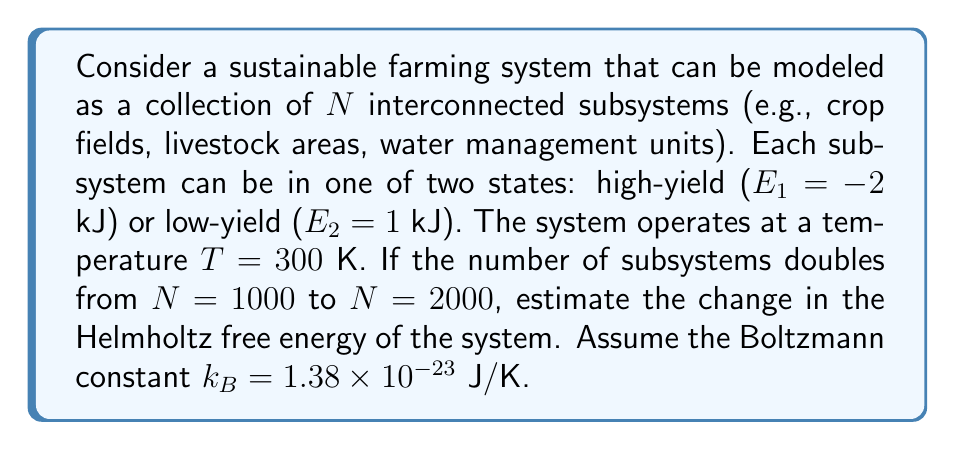Could you help me with this problem? To solve this problem, we'll use the Helmholtz free energy formula and calculate the difference between the two scales:

1) The Helmholtz free energy is given by:
   $$F = -k_B T \ln Z$$
   where $Z$ is the partition function.

2) For a two-state system, the partition function is:
   $$Z = e^{-\beta E_1} + e^{-\beta E_2}$$
   where $\beta = \frac{1}{k_B T}$

3) Calculate $\beta$:
   $$\beta = \frac{1}{(1.38 \times 10^{-23} \text{ J/K})(300 \text{ K})} = 2.415 \times 10^{20} \text{ J}^{-1}$$

4) Calculate $Z$ for a single subsystem:
   $$Z = e^{-(2.415 \times 10^{20} \text{ J}^{-1})(-2 \times 10^{-3} \text{ J})} + e^{-(2.415 \times 10^{20} \text{ J}^{-1})(1 \times 10^{-3} \text{ J})}$$
   $$Z = e^{4.83 \times 10^{17}} + e^{-2.415 \times 10^{17}} \approx e^{4.83 \times 10^{17}}$$

5) For $N$ independent subsystems, $Z_N = Z^N$. So, the free energy for $N$ subsystems is:
   $$F_N = -k_B T N \ln Z$$

6) Calculate the change in free energy:
   $$\Delta F = F_{2000} - F_{1000} = -k_B T (2000 \ln Z - 1000 \ln Z)$$
   $$\Delta F = -k_B T (1000 \ln Z)$$

7) Substitute the values:
   $$\Delta F = -(1.38 \times 10^{-23} \text{ J/K})(300 \text{ K})(1000)(4.83 \times 10^{17})$$
   $$\Delta F = -2.00 \times 10^{-1} \text{ J}$$
Answer: $-0.200$ J 